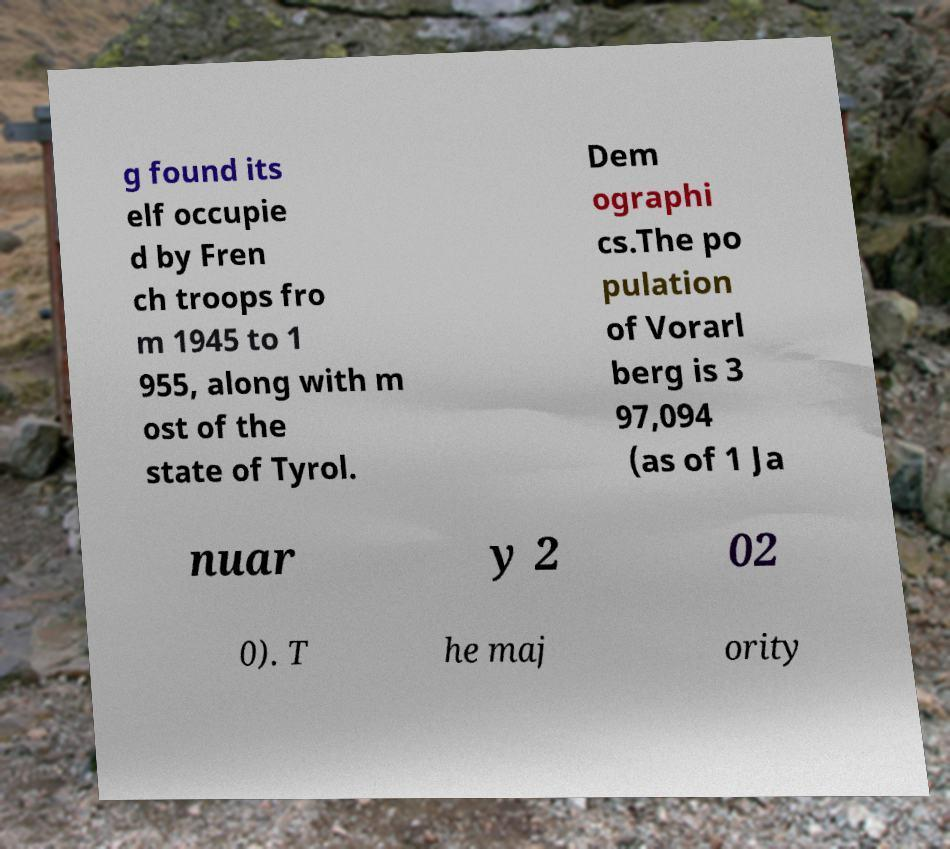For documentation purposes, I need the text within this image transcribed. Could you provide that? g found its elf occupie d by Fren ch troops fro m 1945 to 1 955, along with m ost of the state of Tyrol. Dem ographi cs.The po pulation of Vorarl berg is 3 97,094 (as of 1 Ja nuar y 2 02 0). T he maj ority 